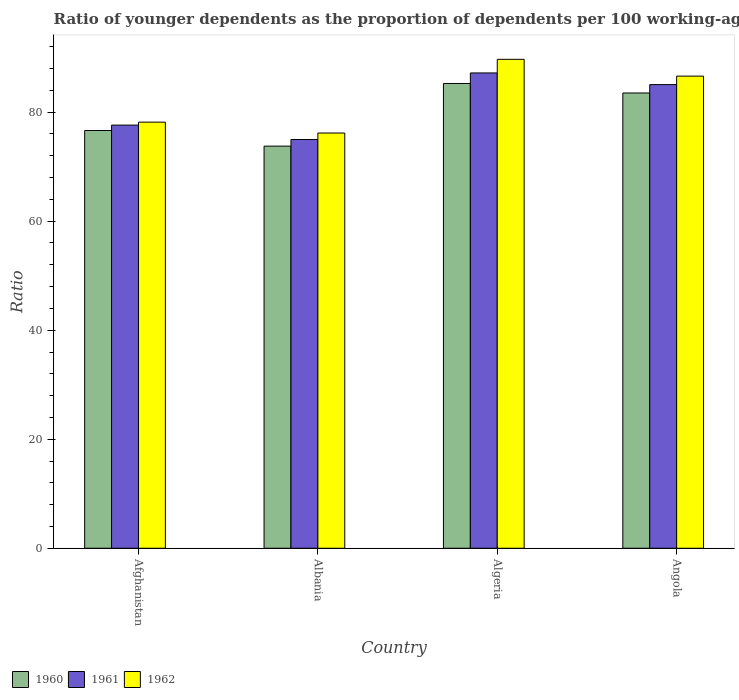How many different coloured bars are there?
Your response must be concise. 3. What is the label of the 3rd group of bars from the left?
Ensure brevity in your answer.  Algeria. What is the age dependency ratio(young) in 1962 in Afghanistan?
Your answer should be compact. 78.17. Across all countries, what is the maximum age dependency ratio(young) in 1960?
Your answer should be very brief. 85.26. Across all countries, what is the minimum age dependency ratio(young) in 1961?
Ensure brevity in your answer.  74.98. In which country was the age dependency ratio(young) in 1960 maximum?
Provide a succinct answer. Algeria. In which country was the age dependency ratio(young) in 1961 minimum?
Give a very brief answer. Albania. What is the total age dependency ratio(young) in 1960 in the graph?
Ensure brevity in your answer.  319.17. What is the difference between the age dependency ratio(young) in 1960 in Algeria and that in Angola?
Ensure brevity in your answer.  1.74. What is the difference between the age dependency ratio(young) in 1961 in Algeria and the age dependency ratio(young) in 1960 in Albania?
Provide a short and direct response. 13.42. What is the average age dependency ratio(young) in 1960 per country?
Offer a terse response. 79.79. What is the difference between the age dependency ratio(young) of/in 1962 and age dependency ratio(young) of/in 1960 in Albania?
Offer a terse response. 2.4. In how many countries, is the age dependency ratio(young) in 1961 greater than 8?
Your answer should be very brief. 4. What is the ratio of the age dependency ratio(young) in 1961 in Algeria to that in Angola?
Your answer should be very brief. 1.03. What is the difference between the highest and the second highest age dependency ratio(young) in 1961?
Offer a terse response. -7.43. What is the difference between the highest and the lowest age dependency ratio(young) in 1961?
Offer a terse response. 12.21. In how many countries, is the age dependency ratio(young) in 1961 greater than the average age dependency ratio(young) in 1961 taken over all countries?
Make the answer very short. 2. What is the difference between two consecutive major ticks on the Y-axis?
Provide a short and direct response. 20. Does the graph contain grids?
Your answer should be very brief. No. How are the legend labels stacked?
Ensure brevity in your answer.  Horizontal. What is the title of the graph?
Offer a very short reply. Ratio of younger dependents as the proportion of dependents per 100 working-age population. What is the label or title of the Y-axis?
Give a very brief answer. Ratio. What is the Ratio of 1960 in Afghanistan?
Your answer should be compact. 76.63. What is the Ratio in 1961 in Afghanistan?
Offer a terse response. 77.62. What is the Ratio of 1962 in Afghanistan?
Your answer should be very brief. 78.17. What is the Ratio in 1960 in Albania?
Give a very brief answer. 73.77. What is the Ratio of 1961 in Albania?
Provide a succinct answer. 74.98. What is the Ratio in 1962 in Albania?
Provide a succinct answer. 76.17. What is the Ratio of 1960 in Algeria?
Your response must be concise. 85.26. What is the Ratio in 1961 in Algeria?
Your response must be concise. 87.19. What is the Ratio of 1962 in Algeria?
Give a very brief answer. 89.69. What is the Ratio in 1960 in Angola?
Make the answer very short. 83.52. What is the Ratio in 1961 in Angola?
Offer a terse response. 85.05. What is the Ratio of 1962 in Angola?
Keep it short and to the point. 86.61. Across all countries, what is the maximum Ratio of 1960?
Your answer should be compact. 85.26. Across all countries, what is the maximum Ratio of 1961?
Offer a terse response. 87.19. Across all countries, what is the maximum Ratio in 1962?
Offer a terse response. 89.69. Across all countries, what is the minimum Ratio in 1960?
Provide a short and direct response. 73.77. Across all countries, what is the minimum Ratio in 1961?
Ensure brevity in your answer.  74.98. Across all countries, what is the minimum Ratio in 1962?
Offer a very short reply. 76.17. What is the total Ratio of 1960 in the graph?
Provide a short and direct response. 319.17. What is the total Ratio in 1961 in the graph?
Make the answer very short. 324.85. What is the total Ratio in 1962 in the graph?
Keep it short and to the point. 330.64. What is the difference between the Ratio in 1960 in Afghanistan and that in Albania?
Your response must be concise. 2.86. What is the difference between the Ratio of 1961 in Afghanistan and that in Albania?
Ensure brevity in your answer.  2.64. What is the difference between the Ratio of 1962 in Afghanistan and that in Albania?
Keep it short and to the point. 1.99. What is the difference between the Ratio of 1960 in Afghanistan and that in Algeria?
Keep it short and to the point. -8.63. What is the difference between the Ratio of 1961 in Afghanistan and that in Algeria?
Your answer should be very brief. -9.57. What is the difference between the Ratio of 1962 in Afghanistan and that in Algeria?
Provide a succinct answer. -11.53. What is the difference between the Ratio of 1960 in Afghanistan and that in Angola?
Provide a short and direct response. -6.88. What is the difference between the Ratio in 1961 in Afghanistan and that in Angola?
Give a very brief answer. -7.43. What is the difference between the Ratio of 1962 in Afghanistan and that in Angola?
Offer a very short reply. -8.44. What is the difference between the Ratio of 1960 in Albania and that in Algeria?
Give a very brief answer. -11.49. What is the difference between the Ratio in 1961 in Albania and that in Algeria?
Keep it short and to the point. -12.21. What is the difference between the Ratio in 1962 in Albania and that in Algeria?
Ensure brevity in your answer.  -13.52. What is the difference between the Ratio of 1960 in Albania and that in Angola?
Provide a short and direct response. -9.75. What is the difference between the Ratio in 1961 in Albania and that in Angola?
Your answer should be very brief. -10.07. What is the difference between the Ratio in 1962 in Albania and that in Angola?
Your answer should be very brief. -10.44. What is the difference between the Ratio in 1960 in Algeria and that in Angola?
Provide a short and direct response. 1.74. What is the difference between the Ratio of 1961 in Algeria and that in Angola?
Make the answer very short. 2.14. What is the difference between the Ratio of 1962 in Algeria and that in Angola?
Keep it short and to the point. 3.08. What is the difference between the Ratio of 1960 in Afghanistan and the Ratio of 1961 in Albania?
Ensure brevity in your answer.  1.65. What is the difference between the Ratio of 1960 in Afghanistan and the Ratio of 1962 in Albania?
Provide a short and direct response. 0.46. What is the difference between the Ratio in 1961 in Afghanistan and the Ratio in 1962 in Albania?
Your answer should be very brief. 1.45. What is the difference between the Ratio in 1960 in Afghanistan and the Ratio in 1961 in Algeria?
Make the answer very short. -10.56. What is the difference between the Ratio of 1960 in Afghanistan and the Ratio of 1962 in Algeria?
Keep it short and to the point. -13.06. What is the difference between the Ratio in 1961 in Afghanistan and the Ratio in 1962 in Algeria?
Offer a terse response. -12.07. What is the difference between the Ratio in 1960 in Afghanistan and the Ratio in 1961 in Angola?
Your response must be concise. -8.42. What is the difference between the Ratio of 1960 in Afghanistan and the Ratio of 1962 in Angola?
Make the answer very short. -9.98. What is the difference between the Ratio in 1961 in Afghanistan and the Ratio in 1962 in Angola?
Your response must be concise. -8.99. What is the difference between the Ratio in 1960 in Albania and the Ratio in 1961 in Algeria?
Ensure brevity in your answer.  -13.42. What is the difference between the Ratio in 1960 in Albania and the Ratio in 1962 in Algeria?
Provide a succinct answer. -15.92. What is the difference between the Ratio in 1961 in Albania and the Ratio in 1962 in Algeria?
Keep it short and to the point. -14.71. What is the difference between the Ratio in 1960 in Albania and the Ratio in 1961 in Angola?
Provide a succinct answer. -11.29. What is the difference between the Ratio in 1960 in Albania and the Ratio in 1962 in Angola?
Your answer should be very brief. -12.84. What is the difference between the Ratio in 1961 in Albania and the Ratio in 1962 in Angola?
Give a very brief answer. -11.63. What is the difference between the Ratio in 1960 in Algeria and the Ratio in 1961 in Angola?
Your answer should be very brief. 0.2. What is the difference between the Ratio in 1960 in Algeria and the Ratio in 1962 in Angola?
Make the answer very short. -1.35. What is the difference between the Ratio in 1961 in Algeria and the Ratio in 1962 in Angola?
Your response must be concise. 0.58. What is the average Ratio in 1960 per country?
Your response must be concise. 79.79. What is the average Ratio of 1961 per country?
Keep it short and to the point. 81.21. What is the average Ratio of 1962 per country?
Your answer should be compact. 82.66. What is the difference between the Ratio of 1960 and Ratio of 1961 in Afghanistan?
Give a very brief answer. -0.99. What is the difference between the Ratio of 1960 and Ratio of 1962 in Afghanistan?
Give a very brief answer. -1.53. What is the difference between the Ratio in 1961 and Ratio in 1962 in Afghanistan?
Your response must be concise. -0.54. What is the difference between the Ratio in 1960 and Ratio in 1961 in Albania?
Give a very brief answer. -1.21. What is the difference between the Ratio of 1960 and Ratio of 1962 in Albania?
Give a very brief answer. -2.4. What is the difference between the Ratio in 1961 and Ratio in 1962 in Albania?
Make the answer very short. -1.19. What is the difference between the Ratio in 1960 and Ratio in 1961 in Algeria?
Make the answer very short. -1.93. What is the difference between the Ratio of 1960 and Ratio of 1962 in Algeria?
Your answer should be compact. -4.43. What is the difference between the Ratio of 1961 and Ratio of 1962 in Algeria?
Keep it short and to the point. -2.5. What is the difference between the Ratio in 1960 and Ratio in 1961 in Angola?
Your answer should be compact. -1.54. What is the difference between the Ratio of 1960 and Ratio of 1962 in Angola?
Provide a short and direct response. -3.09. What is the difference between the Ratio of 1961 and Ratio of 1962 in Angola?
Your answer should be very brief. -1.55. What is the ratio of the Ratio of 1960 in Afghanistan to that in Albania?
Your answer should be very brief. 1.04. What is the ratio of the Ratio in 1961 in Afghanistan to that in Albania?
Offer a very short reply. 1.04. What is the ratio of the Ratio in 1962 in Afghanistan to that in Albania?
Your answer should be compact. 1.03. What is the ratio of the Ratio in 1960 in Afghanistan to that in Algeria?
Give a very brief answer. 0.9. What is the ratio of the Ratio of 1961 in Afghanistan to that in Algeria?
Your answer should be very brief. 0.89. What is the ratio of the Ratio of 1962 in Afghanistan to that in Algeria?
Give a very brief answer. 0.87. What is the ratio of the Ratio in 1960 in Afghanistan to that in Angola?
Make the answer very short. 0.92. What is the ratio of the Ratio of 1961 in Afghanistan to that in Angola?
Give a very brief answer. 0.91. What is the ratio of the Ratio of 1962 in Afghanistan to that in Angola?
Your response must be concise. 0.9. What is the ratio of the Ratio of 1960 in Albania to that in Algeria?
Offer a very short reply. 0.87. What is the ratio of the Ratio in 1961 in Albania to that in Algeria?
Your answer should be very brief. 0.86. What is the ratio of the Ratio in 1962 in Albania to that in Algeria?
Provide a short and direct response. 0.85. What is the ratio of the Ratio in 1960 in Albania to that in Angola?
Ensure brevity in your answer.  0.88. What is the ratio of the Ratio in 1961 in Albania to that in Angola?
Keep it short and to the point. 0.88. What is the ratio of the Ratio of 1962 in Albania to that in Angola?
Your response must be concise. 0.88. What is the ratio of the Ratio in 1960 in Algeria to that in Angola?
Offer a very short reply. 1.02. What is the ratio of the Ratio in 1961 in Algeria to that in Angola?
Your response must be concise. 1.03. What is the ratio of the Ratio in 1962 in Algeria to that in Angola?
Provide a succinct answer. 1.04. What is the difference between the highest and the second highest Ratio of 1960?
Provide a succinct answer. 1.74. What is the difference between the highest and the second highest Ratio of 1961?
Provide a succinct answer. 2.14. What is the difference between the highest and the second highest Ratio of 1962?
Your response must be concise. 3.08. What is the difference between the highest and the lowest Ratio of 1960?
Offer a terse response. 11.49. What is the difference between the highest and the lowest Ratio of 1961?
Provide a short and direct response. 12.21. What is the difference between the highest and the lowest Ratio of 1962?
Offer a terse response. 13.52. 